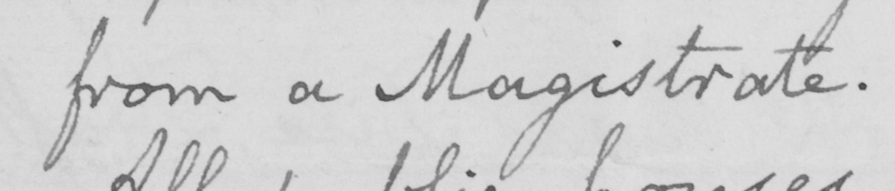Can you read and transcribe this handwriting? from a Magistrate . 